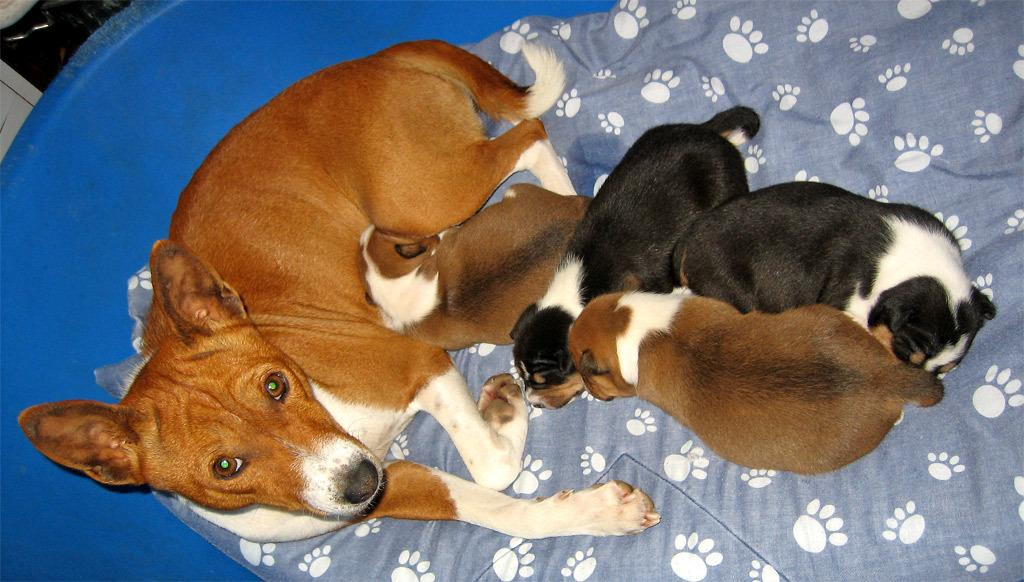What type of animal is present in the image? There is a dog in the image. Are there any other animals in the image besides the dog? Yes, there are puppies in the image. What type of yarn is being used by the committee on the sidewalk in the image? There is no committee, sidewalk, or yarn present in the image. The image only features a dog and puppies. 